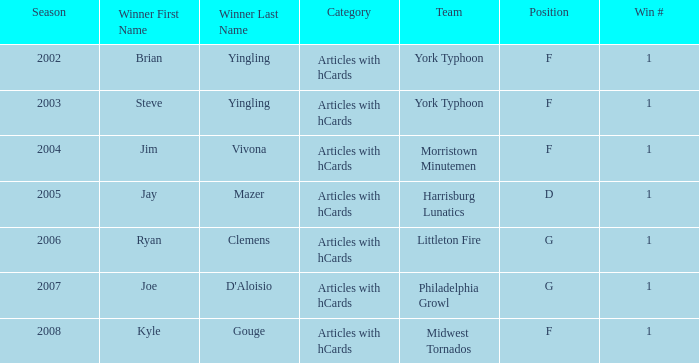Who was the winner in the 2008 season? Kyle Gouge Category:Articles with hCards. 